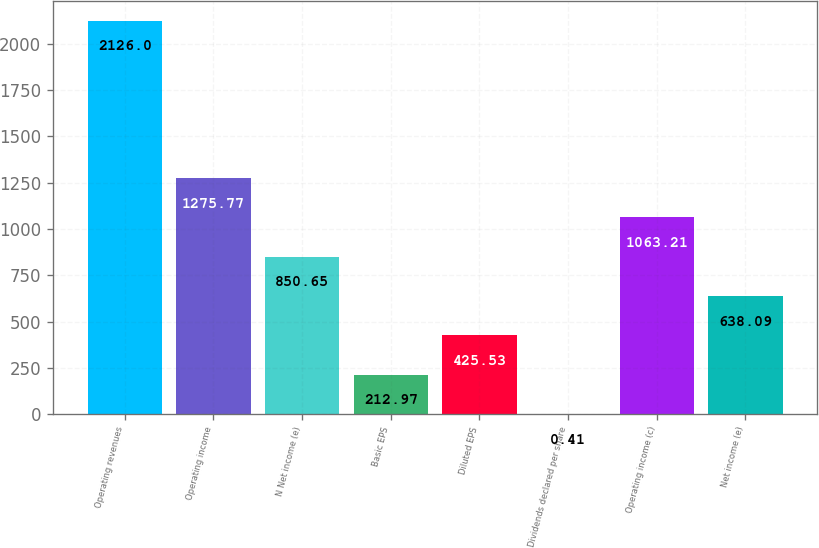Convert chart. <chart><loc_0><loc_0><loc_500><loc_500><bar_chart><fcel>Operating revenues<fcel>Operating income<fcel>N Net income (e)<fcel>Basic EPS<fcel>Diluted EPS<fcel>Dividends declared per share<fcel>Operating income (c)<fcel>Net income (e)<nl><fcel>2126<fcel>1275.77<fcel>850.65<fcel>212.97<fcel>425.53<fcel>0.41<fcel>1063.21<fcel>638.09<nl></chart> 